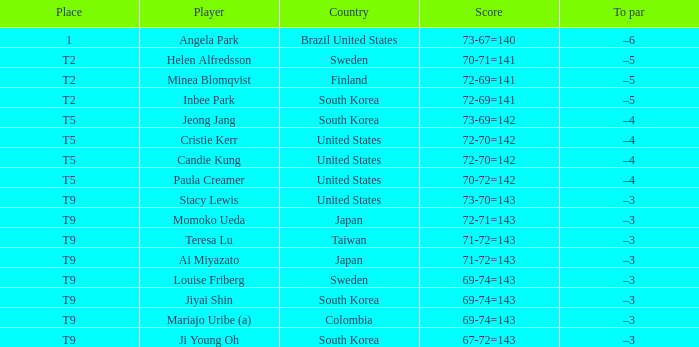What was Momoko Ueda's place? T9. 